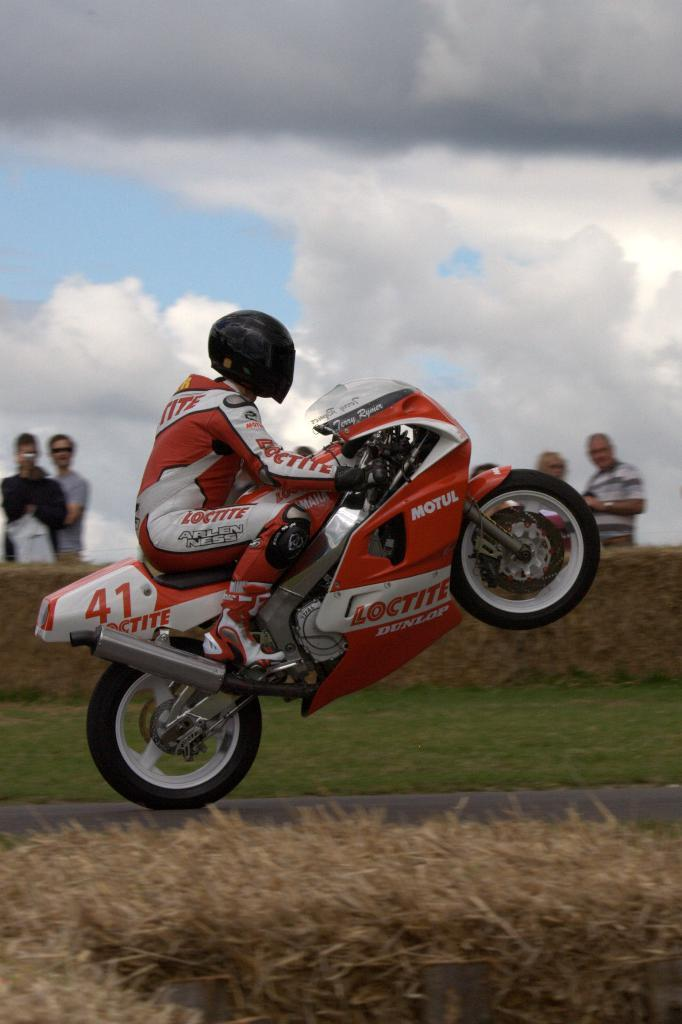What is the main subject of the image? The main subject of the image is a man. What is the man wearing in the image? The man is wearing a helmet in the image. What is the man doing in the image? The man is riding a sports bike in the image. Where is the bike located in the image? The bike is on a road in the image. What can be seen in the background of the image? There is sky visible in the background of the image, with clouds present. Are there any other people in the image? Yes, there are people watching the man in the background. What type of door can be seen in the image? There is no door present in the image. Can you describe the monkey's interaction with the sports bike in the image? There is no monkey present in the image, so it cannot interact with the sports bike. 